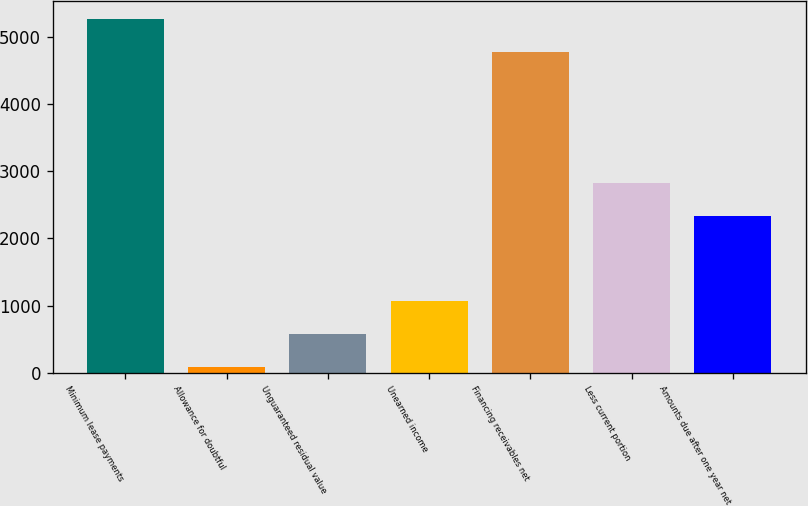<chart> <loc_0><loc_0><loc_500><loc_500><bar_chart><fcel>Minimum lease payments<fcel>Allowance for doubtful<fcel>Unguaranteed residual value<fcel>Unearned income<fcel>Financing receivables net<fcel>Less current portion<fcel>Amounts due after one year net<nl><fcel>5273<fcel>80<fcel>573<fcel>1066<fcel>4780<fcel>2833<fcel>2340<nl></chart> 